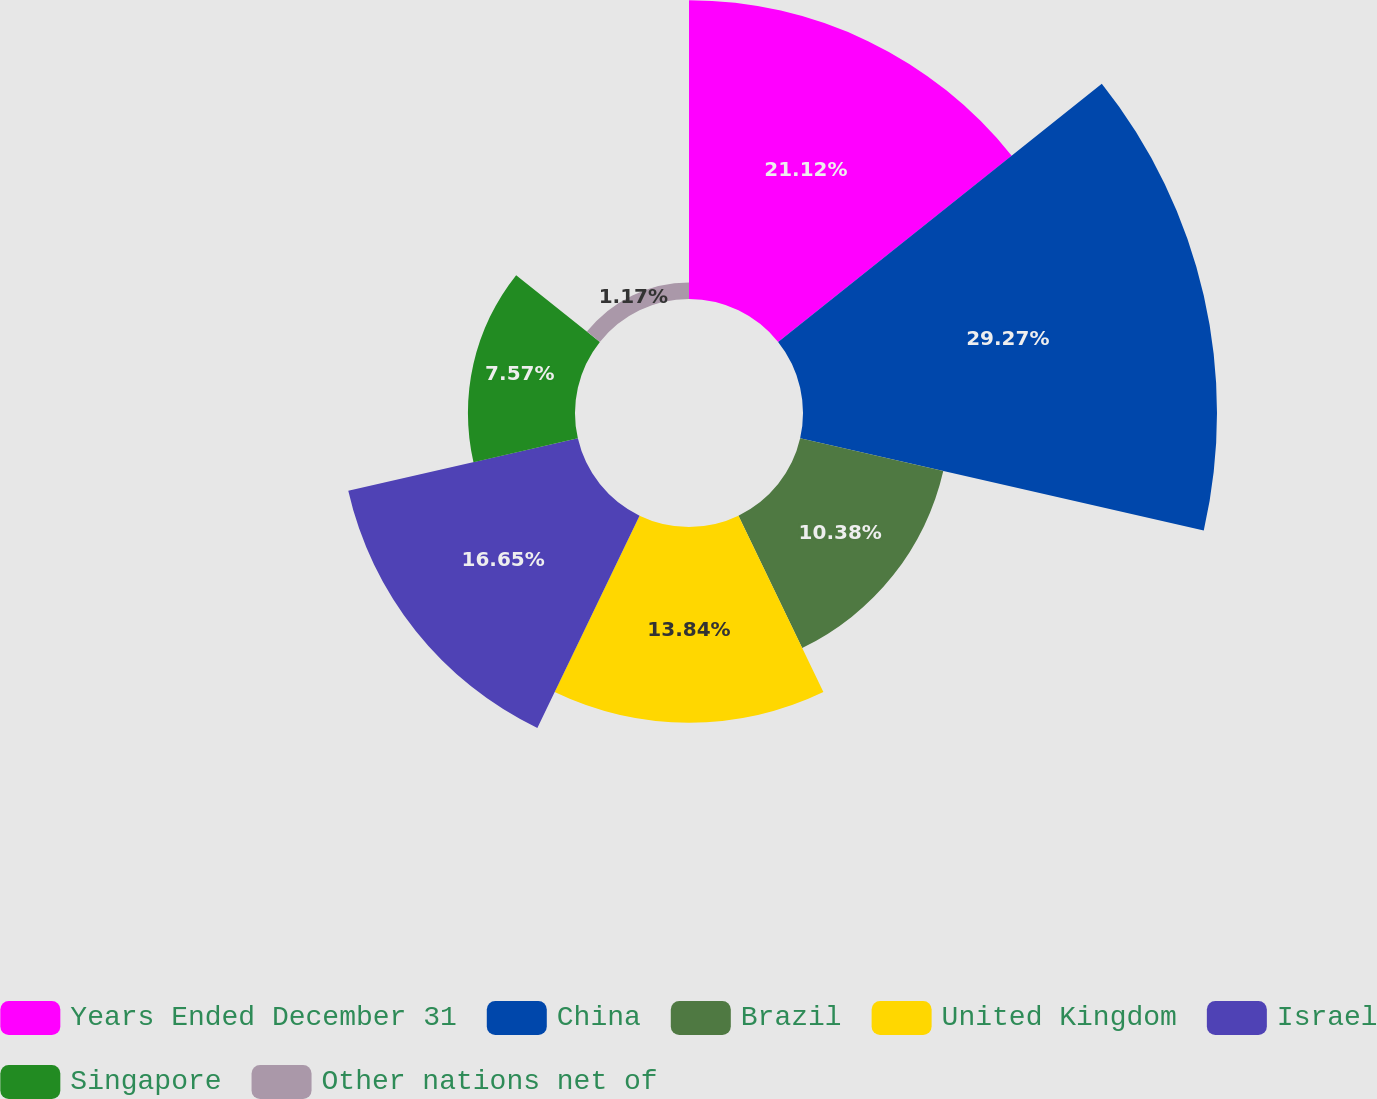Convert chart. <chart><loc_0><loc_0><loc_500><loc_500><pie_chart><fcel>Years Ended December 31<fcel>China<fcel>Brazil<fcel>United Kingdom<fcel>Israel<fcel>Singapore<fcel>Other nations net of<nl><fcel>21.12%<fcel>29.27%<fcel>10.38%<fcel>13.84%<fcel>16.65%<fcel>7.57%<fcel>1.17%<nl></chart> 